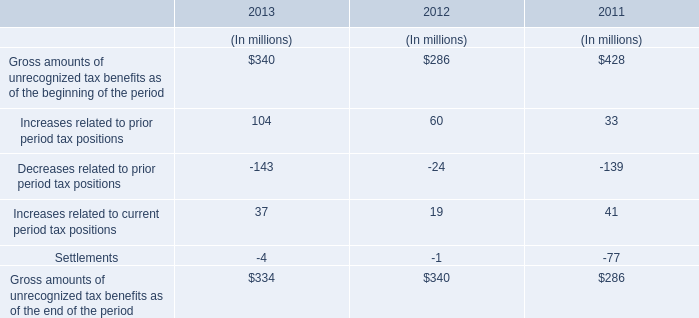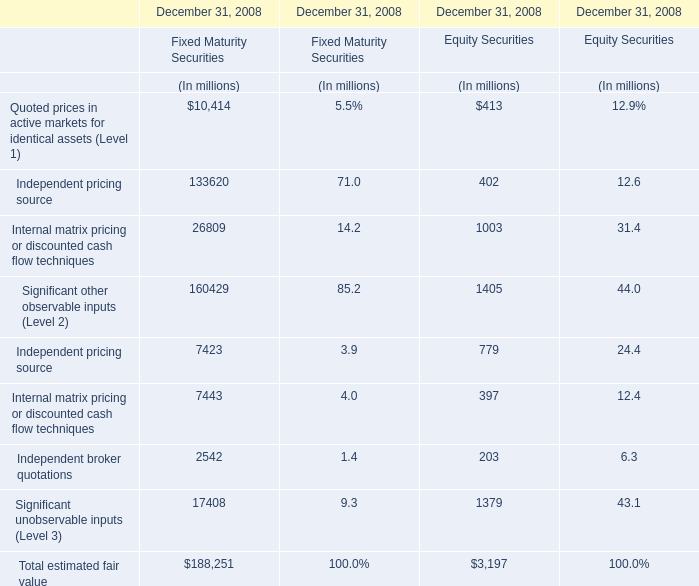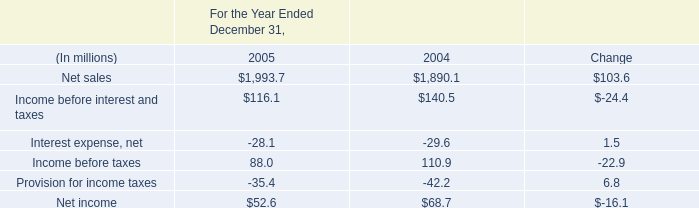What's the 90 % of total Fixed Maturity Securities in 2008? (in million) 
Computations: (188251 * 0.9)
Answer: 169425.9. 